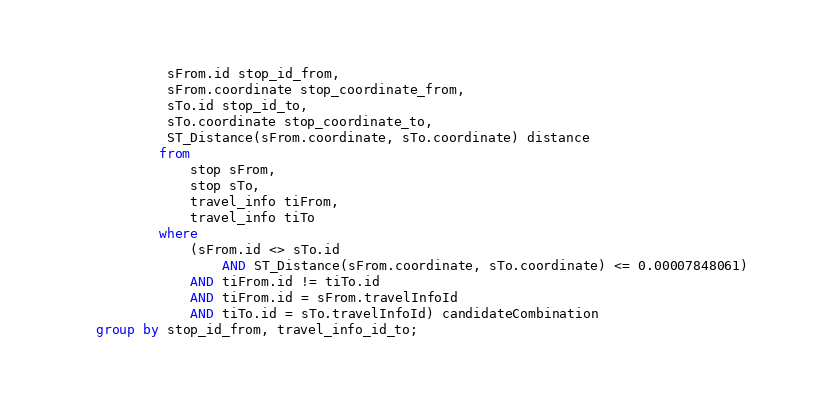Convert code to text. <code><loc_0><loc_0><loc_500><loc_500><_SQL_>			 sFrom.id stop_id_from,
			 sFrom.coordinate stop_coordinate_from,
			 sTo.id stop_id_to,
			 sTo.coordinate stop_coordinate_to,
			 ST_Distance(sFrom.coordinate, sTo.coordinate) distance
			from
				stop sFrom,
				stop sTo,
				travel_info tiFrom,
				travel_info tiTo
			where
				(sFrom.id <> sTo.id
					AND ST_Distance(sFrom.coordinate, sTo.coordinate) <= 0.00007848061)
				AND tiFrom.id != tiTo.id
				AND tiFrom.id = sFrom.travelInfoId
				AND tiTo.id = sTo.travelInfoId) candidateCombination
	group by stop_id_from, travel_info_id_to;
</code> 